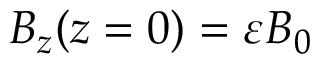Convert formula to latex. <formula><loc_0><loc_0><loc_500><loc_500>B _ { z } ( z = 0 ) = \varepsilon B _ { 0 }</formula> 